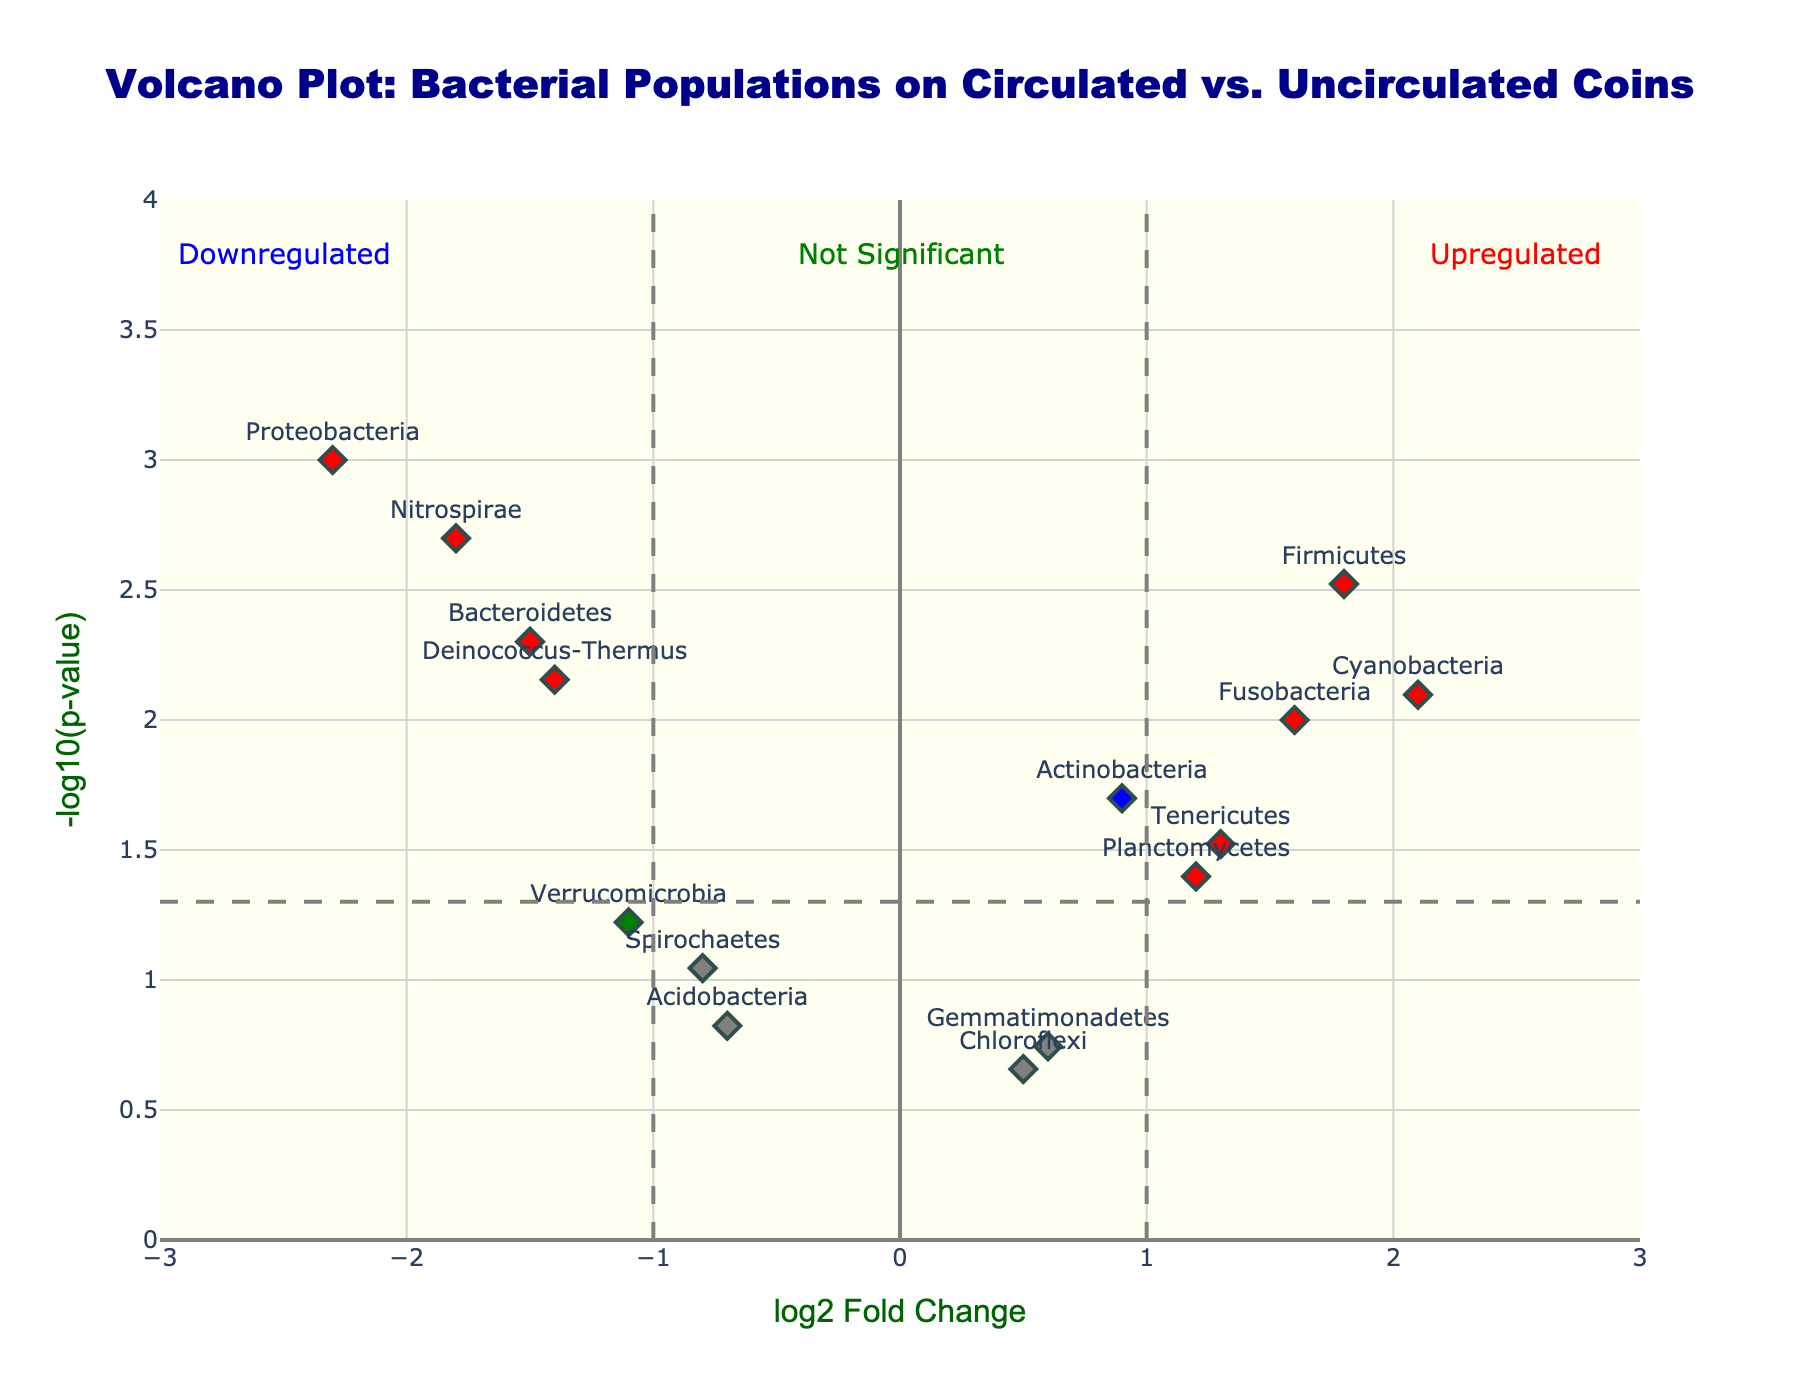How many genes are upregulated? "Upregulated" genes are marked in red on the plot. Count the red markers to determine the number of upregulated genes.
Answer: 4 Which gene has the highest log2 fold change? To find the gene with the highest log2 fold change, look at the farthest point to the right on the x-axis and check its label.
Answer: Cyanobacteria What is the fold change threshold for significance? The threshold lines on the x-axis indicate the log2 fold change thresholds. These lines are positioned at log2 fold change values of -1 and 1.
Answer: ±1 How does the log2 fold change for Verrucomicrobia compare to that of Nitrospirae? Look at the x-axis positions of Verrucomicrobia and Nitrospirae. Verrucomicrobia is slightly less than -1, while Nitrospirae is -1.8. Nitrospirae has a larger absolute negative value.
Answer: Nitrospirae has a larger negative change Which gene has the lowest p-value? On the y-axis, higher values correspond to lower p-values since it’s -log10(p-value). Identify the highest point and check its label.
Answer: Proteobacteria Are there any genes that are not significant but have a high fold change? A significant change requires a fold change >1 and p-value <0.05. Green markers indicate high fold change but non-significance. Check for green markers.
Answer: None What does the color green represent on this plot? Examine the plot legend or explanation above the plot where color coding is explained. Green color refers to genes with high fold change but non-significant p-value (>0.05).
Answer: High fold change, non-significant p-value What is the log2 fold change and p-value for Actinobacteria? Look at the labeled point for Actinobacteria on the plot and refer to the hover text if needed: log2 fold change is 0.9, and the p-value is 0.02.
Answer: log2FC: 0.9, p-value: 0.02 How many genes are downregulated? “Downregulated” genes are marked in blue on the plot. Count the blue markers to determine the number of downregulated genes.
Answer: 4 